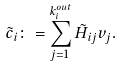Convert formula to latex. <formula><loc_0><loc_0><loc_500><loc_500>\tilde { c } _ { i } \colon = \sum _ { j = 1 } ^ { k ^ { o u t } _ { i } } \tilde { H } _ { i j } v _ { j } .</formula> 